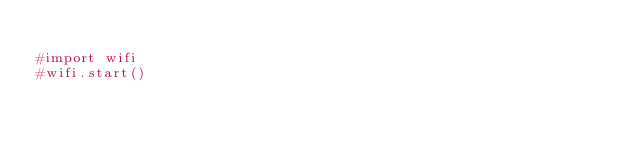Convert code to text. <code><loc_0><loc_0><loc_500><loc_500><_Python_>
#import wifi
#wifi.start()
</code> 